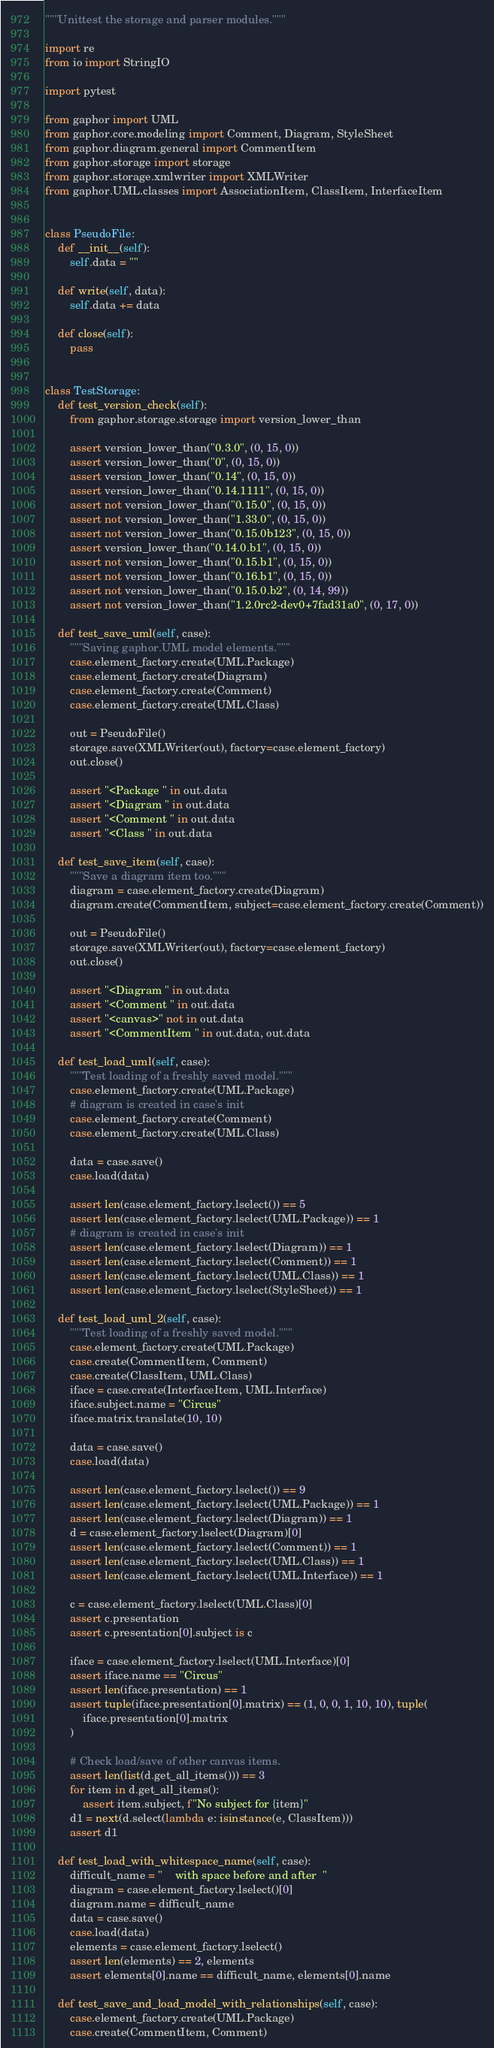Convert code to text. <code><loc_0><loc_0><loc_500><loc_500><_Python_>"""Unittest the storage and parser modules."""

import re
from io import StringIO

import pytest

from gaphor import UML
from gaphor.core.modeling import Comment, Diagram, StyleSheet
from gaphor.diagram.general import CommentItem
from gaphor.storage import storage
from gaphor.storage.xmlwriter import XMLWriter
from gaphor.UML.classes import AssociationItem, ClassItem, InterfaceItem


class PseudoFile:
    def __init__(self):
        self.data = ""

    def write(self, data):
        self.data += data

    def close(self):
        pass


class TestStorage:
    def test_version_check(self):
        from gaphor.storage.storage import version_lower_than

        assert version_lower_than("0.3.0", (0, 15, 0))
        assert version_lower_than("0", (0, 15, 0))
        assert version_lower_than("0.14", (0, 15, 0))
        assert version_lower_than("0.14.1111", (0, 15, 0))
        assert not version_lower_than("0.15.0", (0, 15, 0))
        assert not version_lower_than("1.33.0", (0, 15, 0))
        assert not version_lower_than("0.15.0b123", (0, 15, 0))
        assert version_lower_than("0.14.0.b1", (0, 15, 0))
        assert not version_lower_than("0.15.b1", (0, 15, 0))
        assert not version_lower_than("0.16.b1", (0, 15, 0))
        assert not version_lower_than("0.15.0.b2", (0, 14, 99))
        assert not version_lower_than("1.2.0rc2-dev0+7fad31a0", (0, 17, 0))

    def test_save_uml(self, case):
        """Saving gaphor.UML model elements."""
        case.element_factory.create(UML.Package)
        case.element_factory.create(Diagram)
        case.element_factory.create(Comment)
        case.element_factory.create(UML.Class)

        out = PseudoFile()
        storage.save(XMLWriter(out), factory=case.element_factory)
        out.close()

        assert "<Package " in out.data
        assert "<Diagram " in out.data
        assert "<Comment " in out.data
        assert "<Class " in out.data

    def test_save_item(self, case):
        """Save a diagram item too."""
        diagram = case.element_factory.create(Diagram)
        diagram.create(CommentItem, subject=case.element_factory.create(Comment))

        out = PseudoFile()
        storage.save(XMLWriter(out), factory=case.element_factory)
        out.close()

        assert "<Diagram " in out.data
        assert "<Comment " in out.data
        assert "<canvas>" not in out.data
        assert "<CommentItem " in out.data, out.data

    def test_load_uml(self, case):
        """Test loading of a freshly saved model."""
        case.element_factory.create(UML.Package)
        # diagram is created in case's init
        case.element_factory.create(Comment)
        case.element_factory.create(UML.Class)

        data = case.save()
        case.load(data)

        assert len(case.element_factory.lselect()) == 5
        assert len(case.element_factory.lselect(UML.Package)) == 1
        # diagram is created in case's init
        assert len(case.element_factory.lselect(Diagram)) == 1
        assert len(case.element_factory.lselect(Comment)) == 1
        assert len(case.element_factory.lselect(UML.Class)) == 1
        assert len(case.element_factory.lselect(StyleSheet)) == 1

    def test_load_uml_2(self, case):
        """Test loading of a freshly saved model."""
        case.element_factory.create(UML.Package)
        case.create(CommentItem, Comment)
        case.create(ClassItem, UML.Class)
        iface = case.create(InterfaceItem, UML.Interface)
        iface.subject.name = "Circus"
        iface.matrix.translate(10, 10)

        data = case.save()
        case.load(data)

        assert len(case.element_factory.lselect()) == 9
        assert len(case.element_factory.lselect(UML.Package)) == 1
        assert len(case.element_factory.lselect(Diagram)) == 1
        d = case.element_factory.lselect(Diagram)[0]
        assert len(case.element_factory.lselect(Comment)) == 1
        assert len(case.element_factory.lselect(UML.Class)) == 1
        assert len(case.element_factory.lselect(UML.Interface)) == 1

        c = case.element_factory.lselect(UML.Class)[0]
        assert c.presentation
        assert c.presentation[0].subject is c

        iface = case.element_factory.lselect(UML.Interface)[0]
        assert iface.name == "Circus"
        assert len(iface.presentation) == 1
        assert tuple(iface.presentation[0].matrix) == (1, 0, 0, 1, 10, 10), tuple(
            iface.presentation[0].matrix
        )

        # Check load/save of other canvas items.
        assert len(list(d.get_all_items())) == 3
        for item in d.get_all_items():
            assert item.subject, f"No subject for {item}"
        d1 = next(d.select(lambda e: isinstance(e, ClassItem)))
        assert d1

    def test_load_with_whitespace_name(self, case):
        difficult_name = "    with space before and after  "
        diagram = case.element_factory.lselect()[0]
        diagram.name = difficult_name
        data = case.save()
        case.load(data)
        elements = case.element_factory.lselect()
        assert len(elements) == 2, elements
        assert elements[0].name == difficult_name, elements[0].name

    def test_save_and_load_model_with_relationships(self, case):
        case.element_factory.create(UML.Package)
        case.create(CommentItem, Comment)</code> 